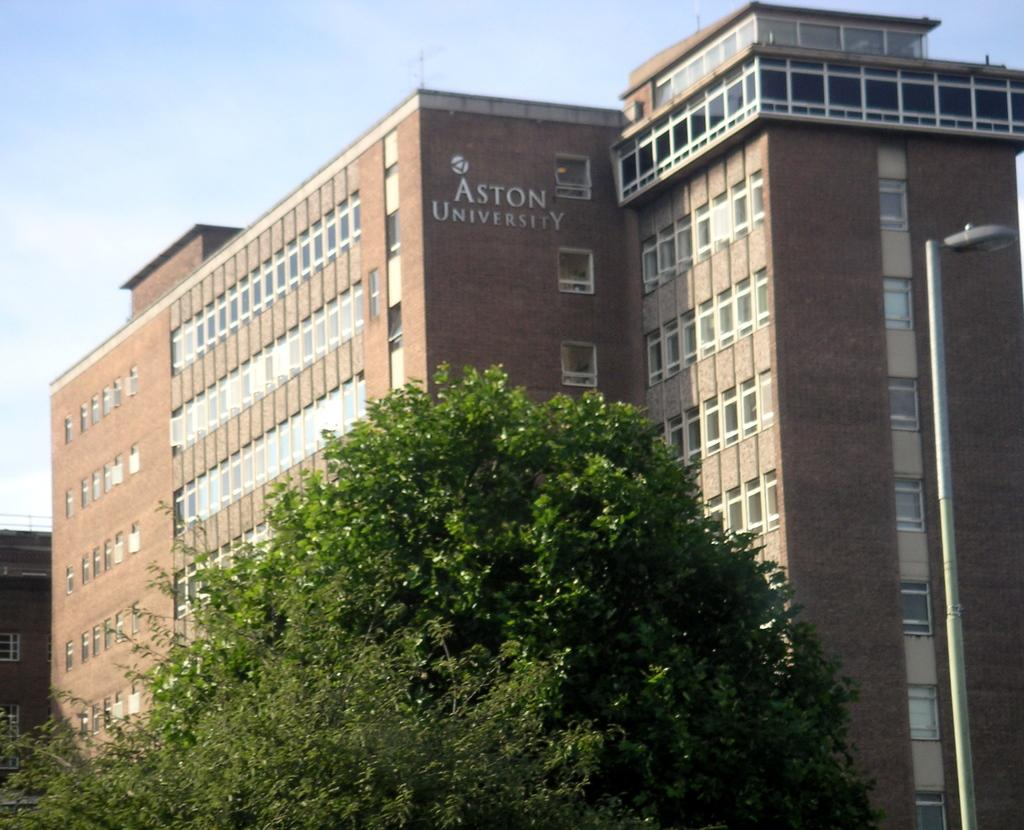What type of structures can be seen in the image? There are buildings in the image. What is written or displayed on a wall in the image? There is text on a wall in the image. What type of vegetation is present in the image? There are trees in the image. What type of street furniture can be seen in the image? There is a light pole in the image. What is visible at the top of the image? The sky is visible at the top of the image. How do the ants contribute to the text on the wall in the image? There are no ants present in the image, and therefore they cannot contribute to the text on the wall. 